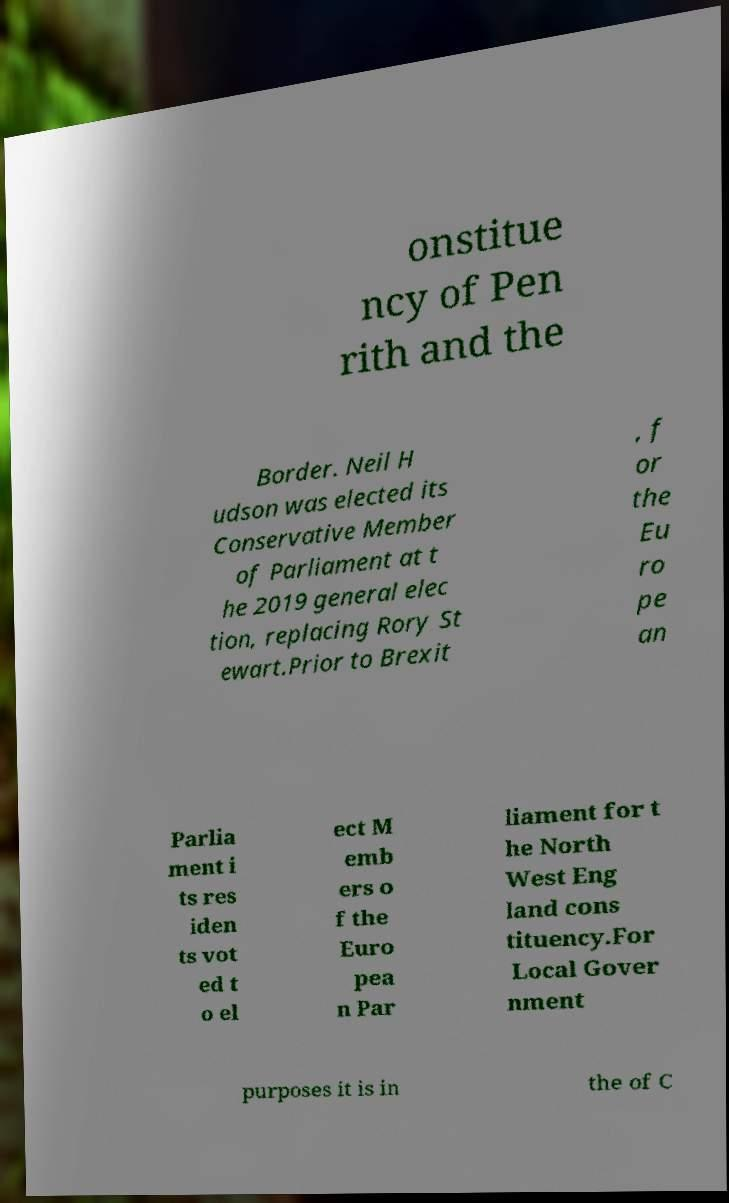For documentation purposes, I need the text within this image transcribed. Could you provide that? onstitue ncy of Pen rith and the Border. Neil H udson was elected its Conservative Member of Parliament at t he 2019 general elec tion, replacing Rory St ewart.Prior to Brexit , f or the Eu ro pe an Parlia ment i ts res iden ts vot ed t o el ect M emb ers o f the Euro pea n Par liament for t he North West Eng land cons tituency.For Local Gover nment purposes it is in the of C 